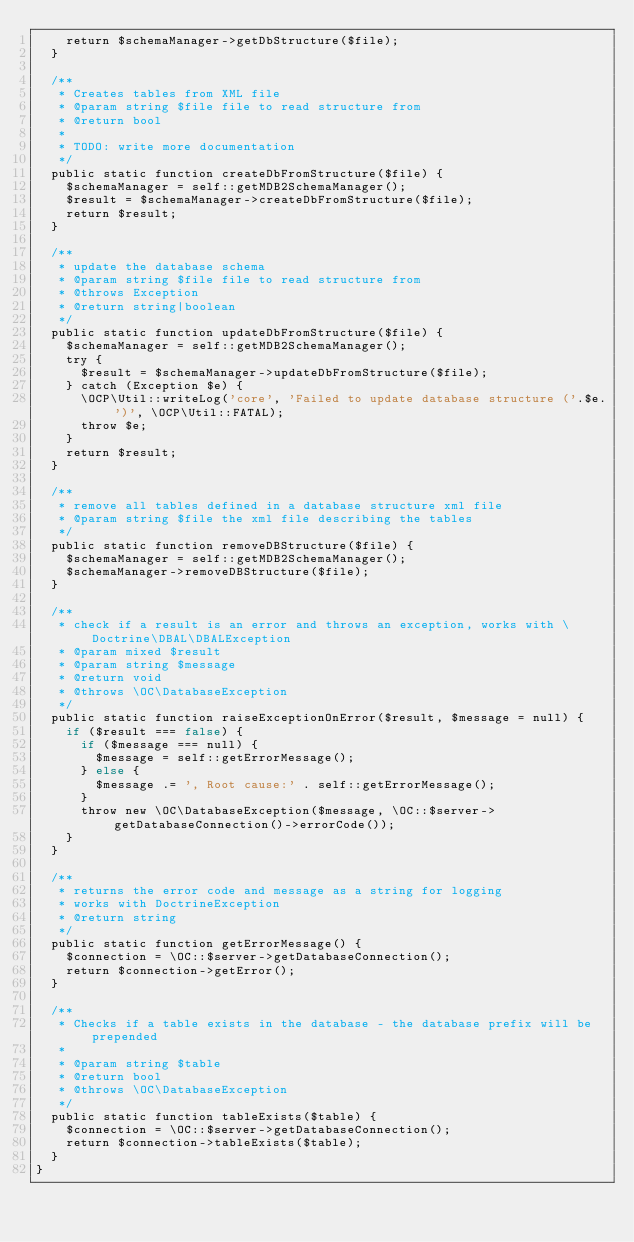Convert code to text. <code><loc_0><loc_0><loc_500><loc_500><_PHP_>		return $schemaManager->getDbStructure($file);
	}

	/**
	 * Creates tables from XML file
	 * @param string $file file to read structure from
	 * @return bool
	 *
	 * TODO: write more documentation
	 */
	public static function createDbFromStructure($file) {
		$schemaManager = self::getMDB2SchemaManager();
		$result = $schemaManager->createDbFromStructure($file);
		return $result;
	}

	/**
	 * update the database schema
	 * @param string $file file to read structure from
	 * @throws Exception
	 * @return string|boolean
	 */
	public static function updateDbFromStructure($file) {
		$schemaManager = self::getMDB2SchemaManager();
		try {
			$result = $schemaManager->updateDbFromStructure($file);
		} catch (Exception $e) {
			\OCP\Util::writeLog('core', 'Failed to update database structure ('.$e.')', \OCP\Util::FATAL);
			throw $e;
		}
		return $result;
	}

	/**
	 * remove all tables defined in a database structure xml file
	 * @param string $file the xml file describing the tables
	 */
	public static function removeDBStructure($file) {
		$schemaManager = self::getMDB2SchemaManager();
		$schemaManager->removeDBStructure($file);
	}

	/**
	 * check if a result is an error and throws an exception, works with \Doctrine\DBAL\DBALException
	 * @param mixed $result
	 * @param string $message
	 * @return void
	 * @throws \OC\DatabaseException
	 */
	public static function raiseExceptionOnError($result, $message = null) {
		if ($result === false) {
			if ($message === null) {
				$message = self::getErrorMessage();
			} else {
				$message .= ', Root cause:' . self::getErrorMessage();
			}
			throw new \OC\DatabaseException($message, \OC::$server->getDatabaseConnection()->errorCode());
		}
	}

	/**
	 * returns the error code and message as a string for logging
	 * works with DoctrineException
	 * @return string
	 */
	public static function getErrorMessage() {
		$connection = \OC::$server->getDatabaseConnection();
		return $connection->getError();
	}

	/**
	 * Checks if a table exists in the database - the database prefix will be prepended
	 *
	 * @param string $table
	 * @return bool
	 * @throws \OC\DatabaseException
	 */
	public static function tableExists($table) {
		$connection = \OC::$server->getDatabaseConnection();
		return $connection->tableExists($table);
	}
}
</code> 